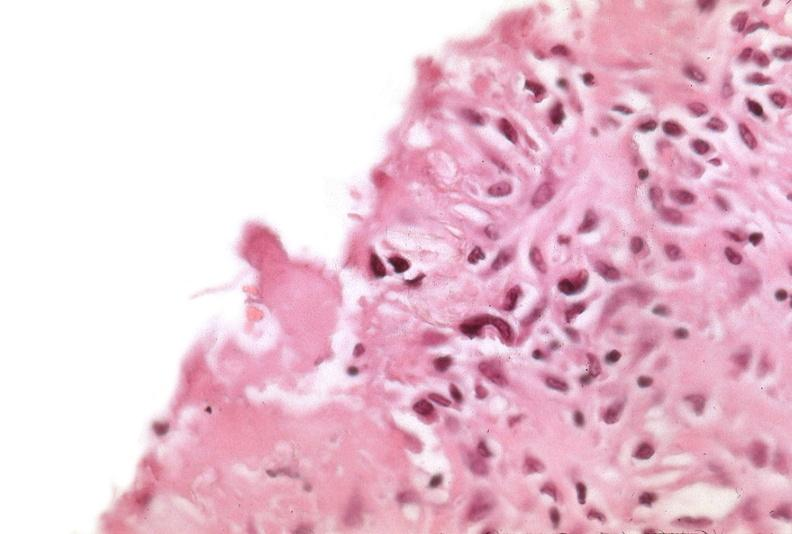where is this?
Answer the question using a single word or phrase. Lung 